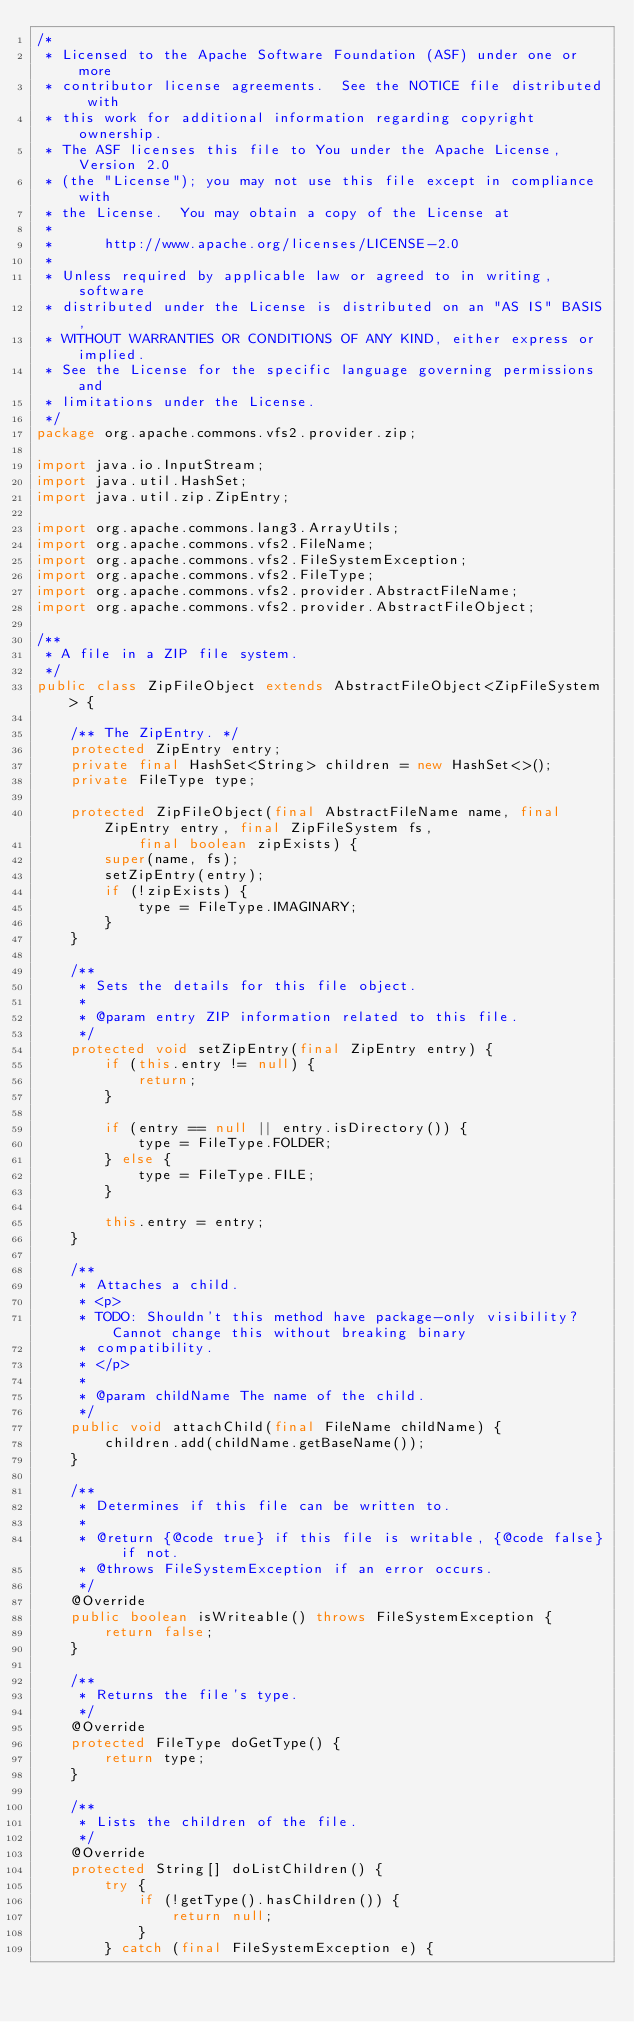Convert code to text. <code><loc_0><loc_0><loc_500><loc_500><_Java_>/*
 * Licensed to the Apache Software Foundation (ASF) under one or more
 * contributor license agreements.  See the NOTICE file distributed with
 * this work for additional information regarding copyright ownership.
 * The ASF licenses this file to You under the Apache License, Version 2.0
 * (the "License"); you may not use this file except in compliance with
 * the License.  You may obtain a copy of the License at
 *
 *      http://www.apache.org/licenses/LICENSE-2.0
 *
 * Unless required by applicable law or agreed to in writing, software
 * distributed under the License is distributed on an "AS IS" BASIS,
 * WITHOUT WARRANTIES OR CONDITIONS OF ANY KIND, either express or implied.
 * See the License for the specific language governing permissions and
 * limitations under the License.
 */
package org.apache.commons.vfs2.provider.zip;

import java.io.InputStream;
import java.util.HashSet;
import java.util.zip.ZipEntry;

import org.apache.commons.lang3.ArrayUtils;
import org.apache.commons.vfs2.FileName;
import org.apache.commons.vfs2.FileSystemException;
import org.apache.commons.vfs2.FileType;
import org.apache.commons.vfs2.provider.AbstractFileName;
import org.apache.commons.vfs2.provider.AbstractFileObject;

/**
 * A file in a ZIP file system.
 */
public class ZipFileObject extends AbstractFileObject<ZipFileSystem> {

    /** The ZipEntry. */
    protected ZipEntry entry;
    private final HashSet<String> children = new HashSet<>();
    private FileType type;

    protected ZipFileObject(final AbstractFileName name, final ZipEntry entry, final ZipFileSystem fs,
            final boolean zipExists) {
        super(name, fs);
        setZipEntry(entry);
        if (!zipExists) {
            type = FileType.IMAGINARY;
        }
    }

    /**
     * Sets the details for this file object.
     *
     * @param entry ZIP information related to this file.
     */
    protected void setZipEntry(final ZipEntry entry) {
        if (this.entry != null) {
            return;
        }

        if (entry == null || entry.isDirectory()) {
            type = FileType.FOLDER;
        } else {
            type = FileType.FILE;
        }

        this.entry = entry;
    }

    /**
     * Attaches a child.
     * <p>
     * TODO: Shouldn't this method have package-only visibility? Cannot change this without breaking binary
     * compatibility.
     * </p>
     *
     * @param childName The name of the child.
     */
    public void attachChild(final FileName childName) {
        children.add(childName.getBaseName());
    }

    /**
     * Determines if this file can be written to.
     *
     * @return {@code true} if this file is writable, {@code false} if not.
     * @throws FileSystemException if an error occurs.
     */
    @Override
    public boolean isWriteable() throws FileSystemException {
        return false;
    }

    /**
     * Returns the file's type.
     */
    @Override
    protected FileType doGetType() {
        return type;
    }

    /**
     * Lists the children of the file.
     */
    @Override
    protected String[] doListChildren() {
        try {
            if (!getType().hasChildren()) {
                return null;
            }
        } catch (final FileSystemException e) {</code> 